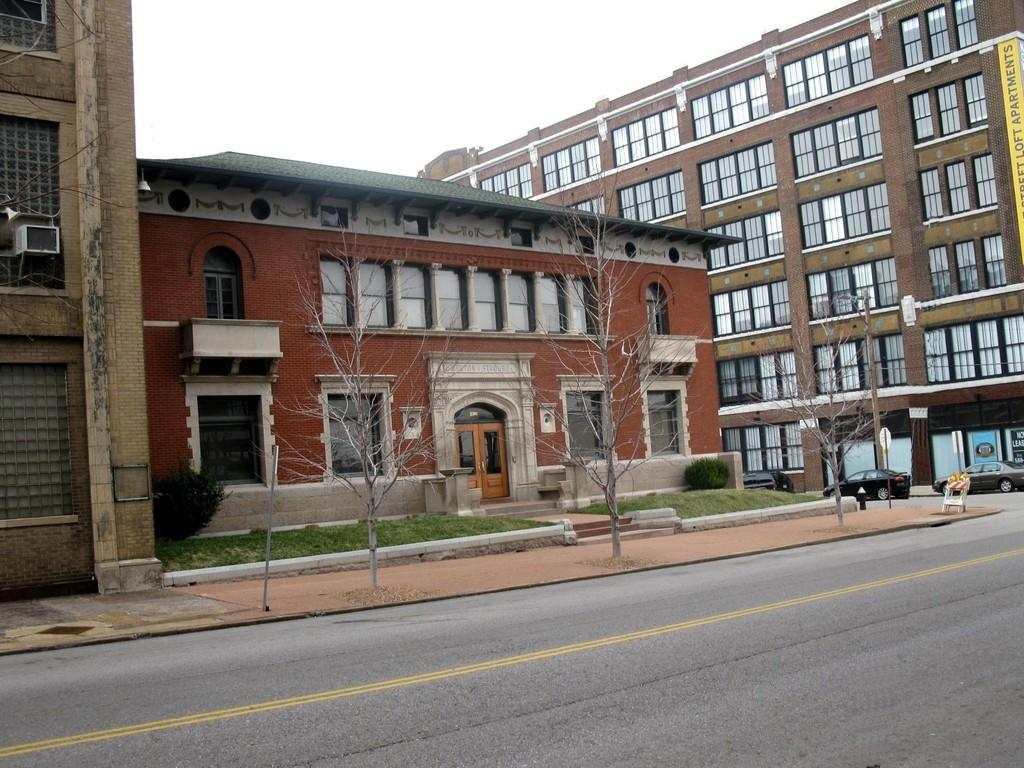What is the main feature of the image? There is a road in the image. What can be seen on the right side of the road? There are vehicles on the right side of the image. What is visible in the background of the image? There are buildings in the background of the image. What type of jewel can be seen glowing on the side of the road in the image? There is no jewel present in the image; it only features a road, vehicles, and buildings. Are there any fairies visible in the image? There are no fairies present in the image. 